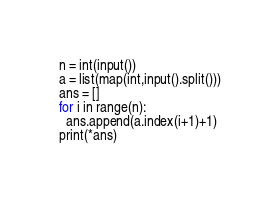Convert code to text. <code><loc_0><loc_0><loc_500><loc_500><_Python_>n = int(input())
a = list(map(int,input().split()))
ans = []
for i in range(n):
  ans.append(a.index(i+1)+1)
print(*ans)</code> 